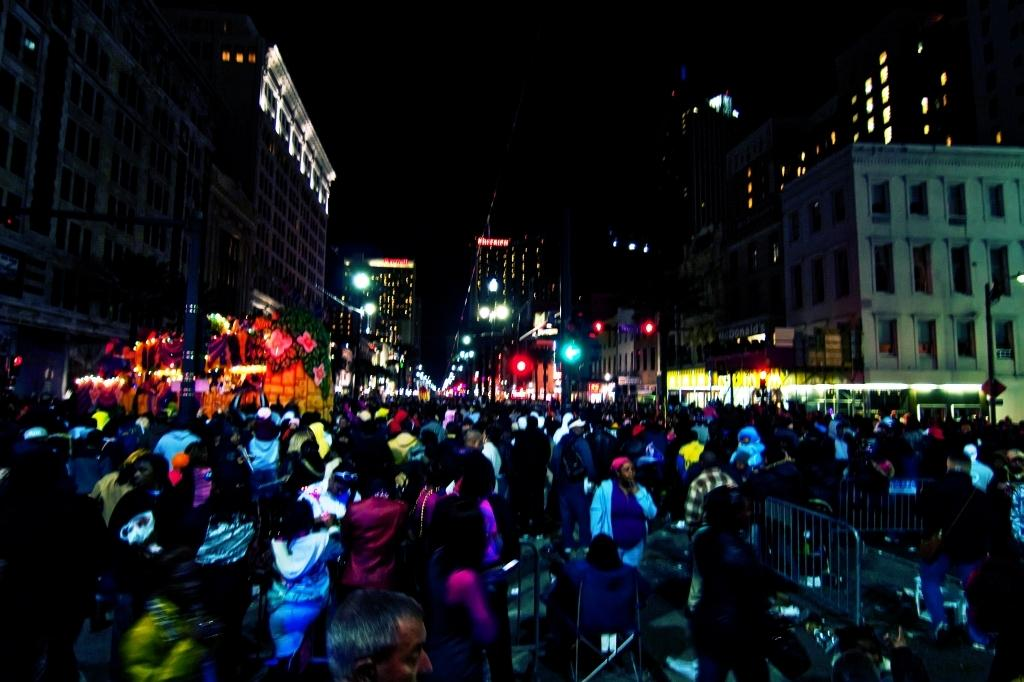What is the lighting condition in the image? The image is taken in a dark environment. What can be seen on the road in the image? There are people on the road in the image. What type of structures are present to control traffic in the image? There are barrier gates in the image. What type of structures are visible in the background of the image? There are buildings in the image. What type of structures are present to provide illumination in the image? There are light poles in the image. What type of apple design can be seen on the back of the people in the image? There is no apple design visible on the back of the people in the image. The image does not show any clothing or accessories with a specific design. 